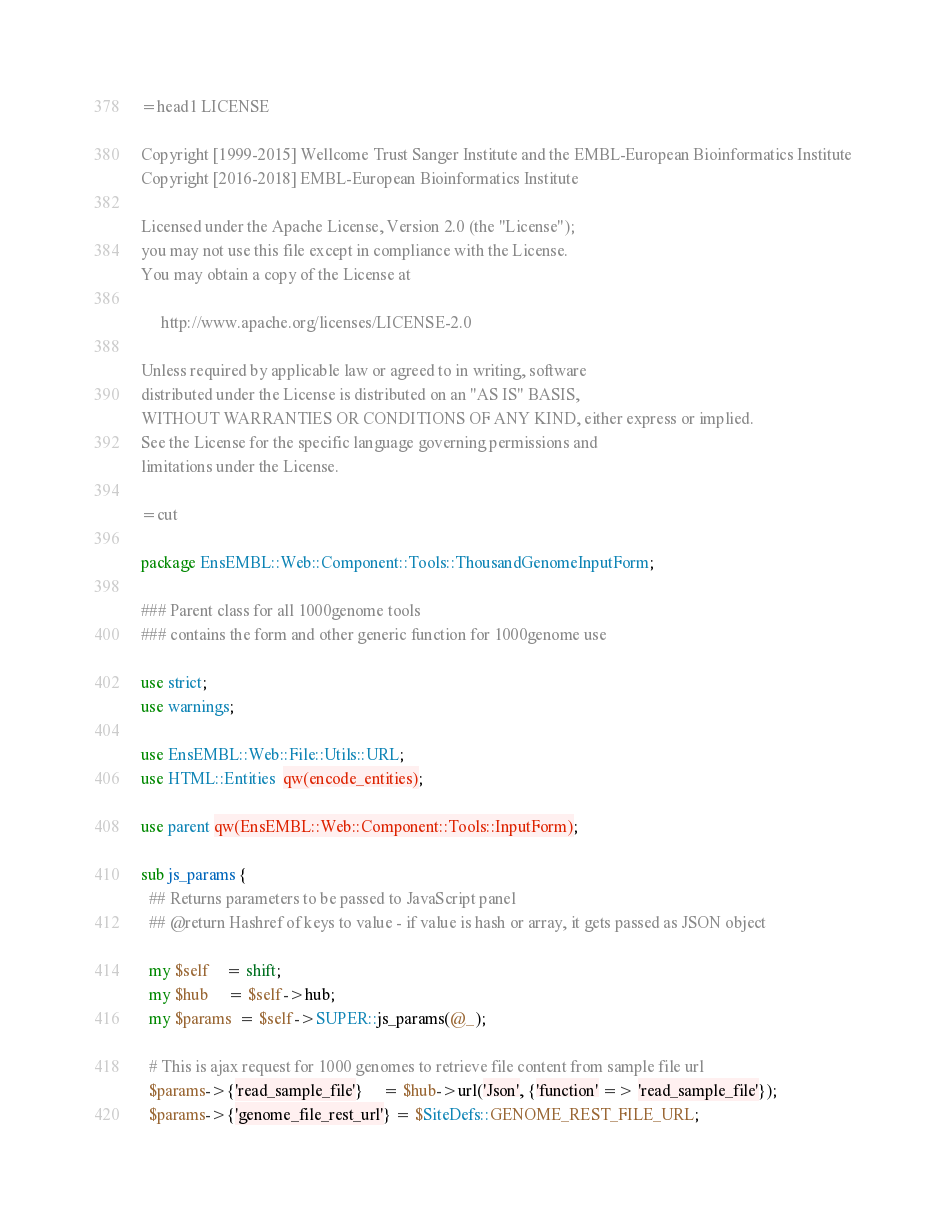Convert code to text. <code><loc_0><loc_0><loc_500><loc_500><_Perl_>=head1 LICENSE

Copyright [1999-2015] Wellcome Trust Sanger Institute and the EMBL-European Bioinformatics Institute
Copyright [2016-2018] EMBL-European Bioinformatics Institute

Licensed under the Apache License, Version 2.0 (the "License");
you may not use this file except in compliance with the License.
You may obtain a copy of the License at

     http://www.apache.org/licenses/LICENSE-2.0

Unless required by applicable law or agreed to in writing, software
distributed under the License is distributed on an "AS IS" BASIS,
WITHOUT WARRANTIES OR CONDITIONS OF ANY KIND, either express or implied.
See the License for the specific language governing permissions and
limitations under the License.

=cut

package EnsEMBL::Web::Component::Tools::ThousandGenomeInputForm;

### Parent class for all 1000genome tools 
### contains the form and other generic function for 1000genome use

use strict;
use warnings;

use EnsEMBL::Web::File::Utils::URL;
use HTML::Entities  qw(encode_entities);

use parent qw(EnsEMBL::Web::Component::Tools::InputForm);

sub js_params {
  ## Returns parameters to be passed to JavaScript panel
  ## @return Hashref of keys to value - if value is hash or array, it gets passed as JSON object

  my $self    = shift;
  my $hub     = $self->hub;
  my $params  = $self->SUPER::js_params(@_);

  # This is ajax request for 1000 genomes to retrieve file content from sample file url
  $params->{'read_sample_file'}     = $hub->url('Json', {'function' => 'read_sample_file'});
  $params->{'genome_file_rest_url'} = $SiteDefs::GENOME_REST_FILE_URL;</code> 